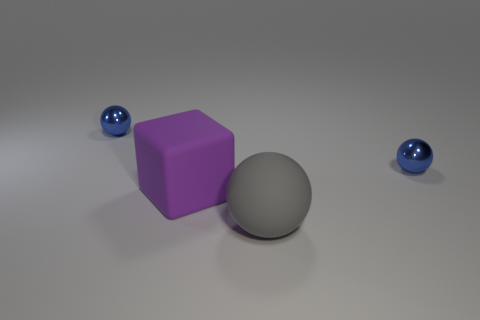Are there any tiny objects that have the same material as the big block?
Offer a very short reply. No. How big is the purple thing?
Give a very brief answer. Large. How many gray objects are small matte spheres or big rubber spheres?
Make the answer very short. 1. How many tiny metallic things have the same shape as the large purple object?
Your response must be concise. 0. How many balls are the same size as the purple matte block?
Provide a short and direct response. 1. What color is the ball in front of the big purple rubber thing?
Keep it short and to the point. Gray. Is the number of objects that are on the right side of the purple object greater than the number of big blocks?
Offer a very short reply. Yes. The block is what color?
Ensure brevity in your answer.  Purple. The tiny blue thing on the left side of the metallic thing that is right of the large thing that is to the right of the purple matte thing is what shape?
Provide a succinct answer. Sphere. There is a sphere that is both to the right of the large purple rubber object and behind the gray matte object; what material is it?
Give a very brief answer. Metal. 